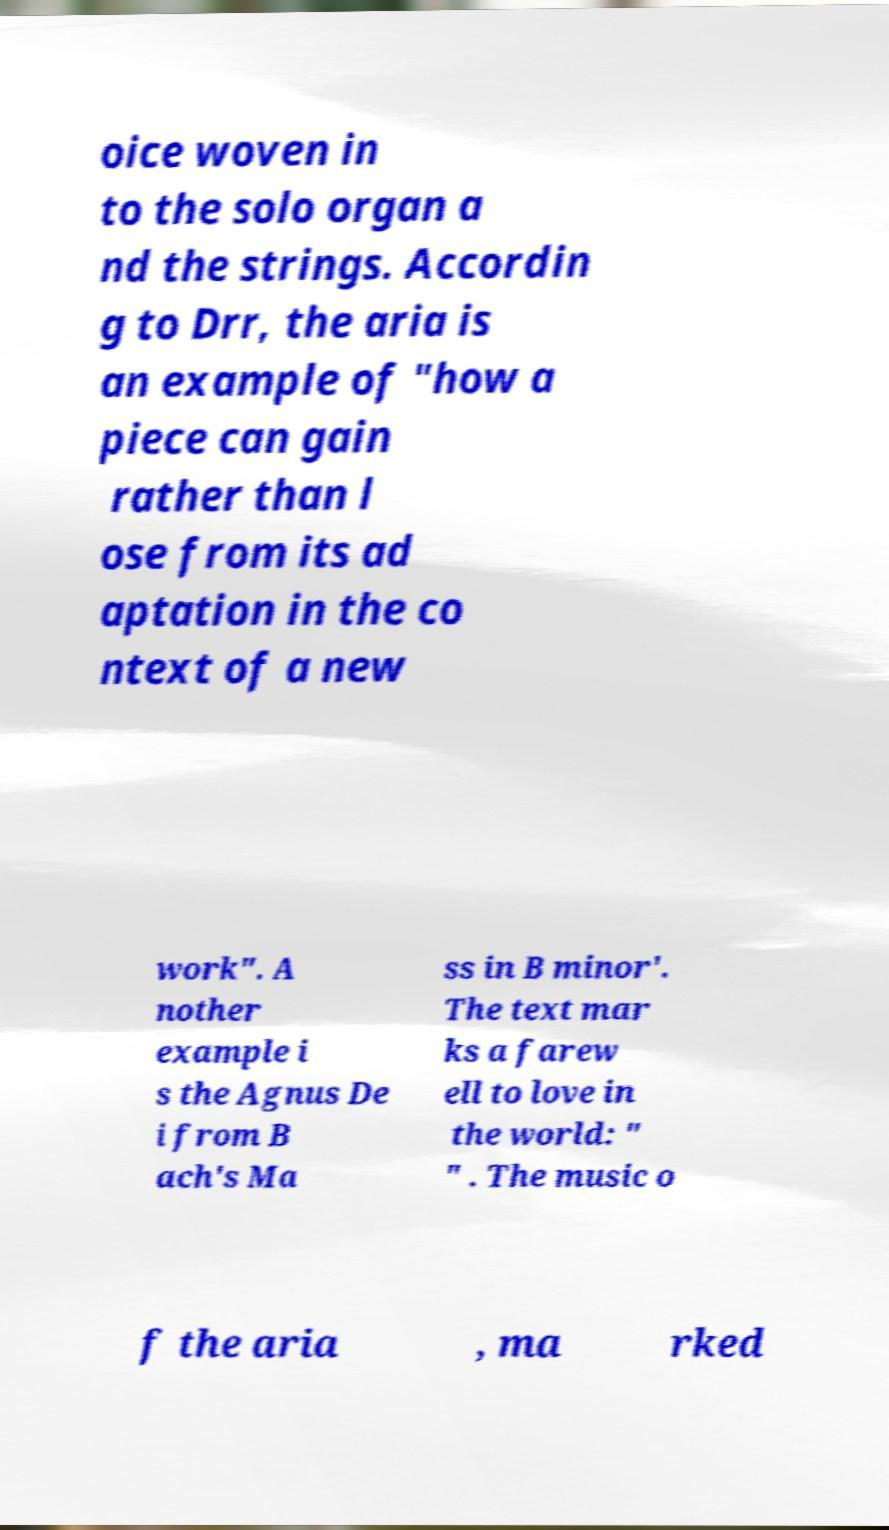Could you extract and type out the text from this image? oice woven in to the solo organ a nd the strings. Accordin g to Drr, the aria is an example of "how a piece can gain rather than l ose from its ad aptation in the co ntext of a new work". A nother example i s the Agnus De i from B ach's Ma ss in B minor'. The text mar ks a farew ell to love in the world: " " . The music o f the aria , ma rked 